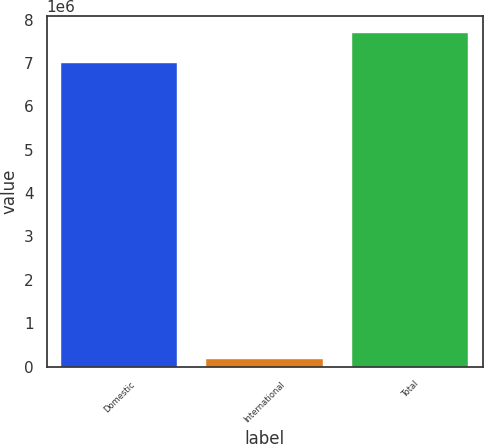<chart> <loc_0><loc_0><loc_500><loc_500><bar_chart><fcel>Domestic<fcel>International<fcel>Total<nl><fcel>6.99161e+06<fcel>170195<fcel>7.69078e+06<nl></chart> 